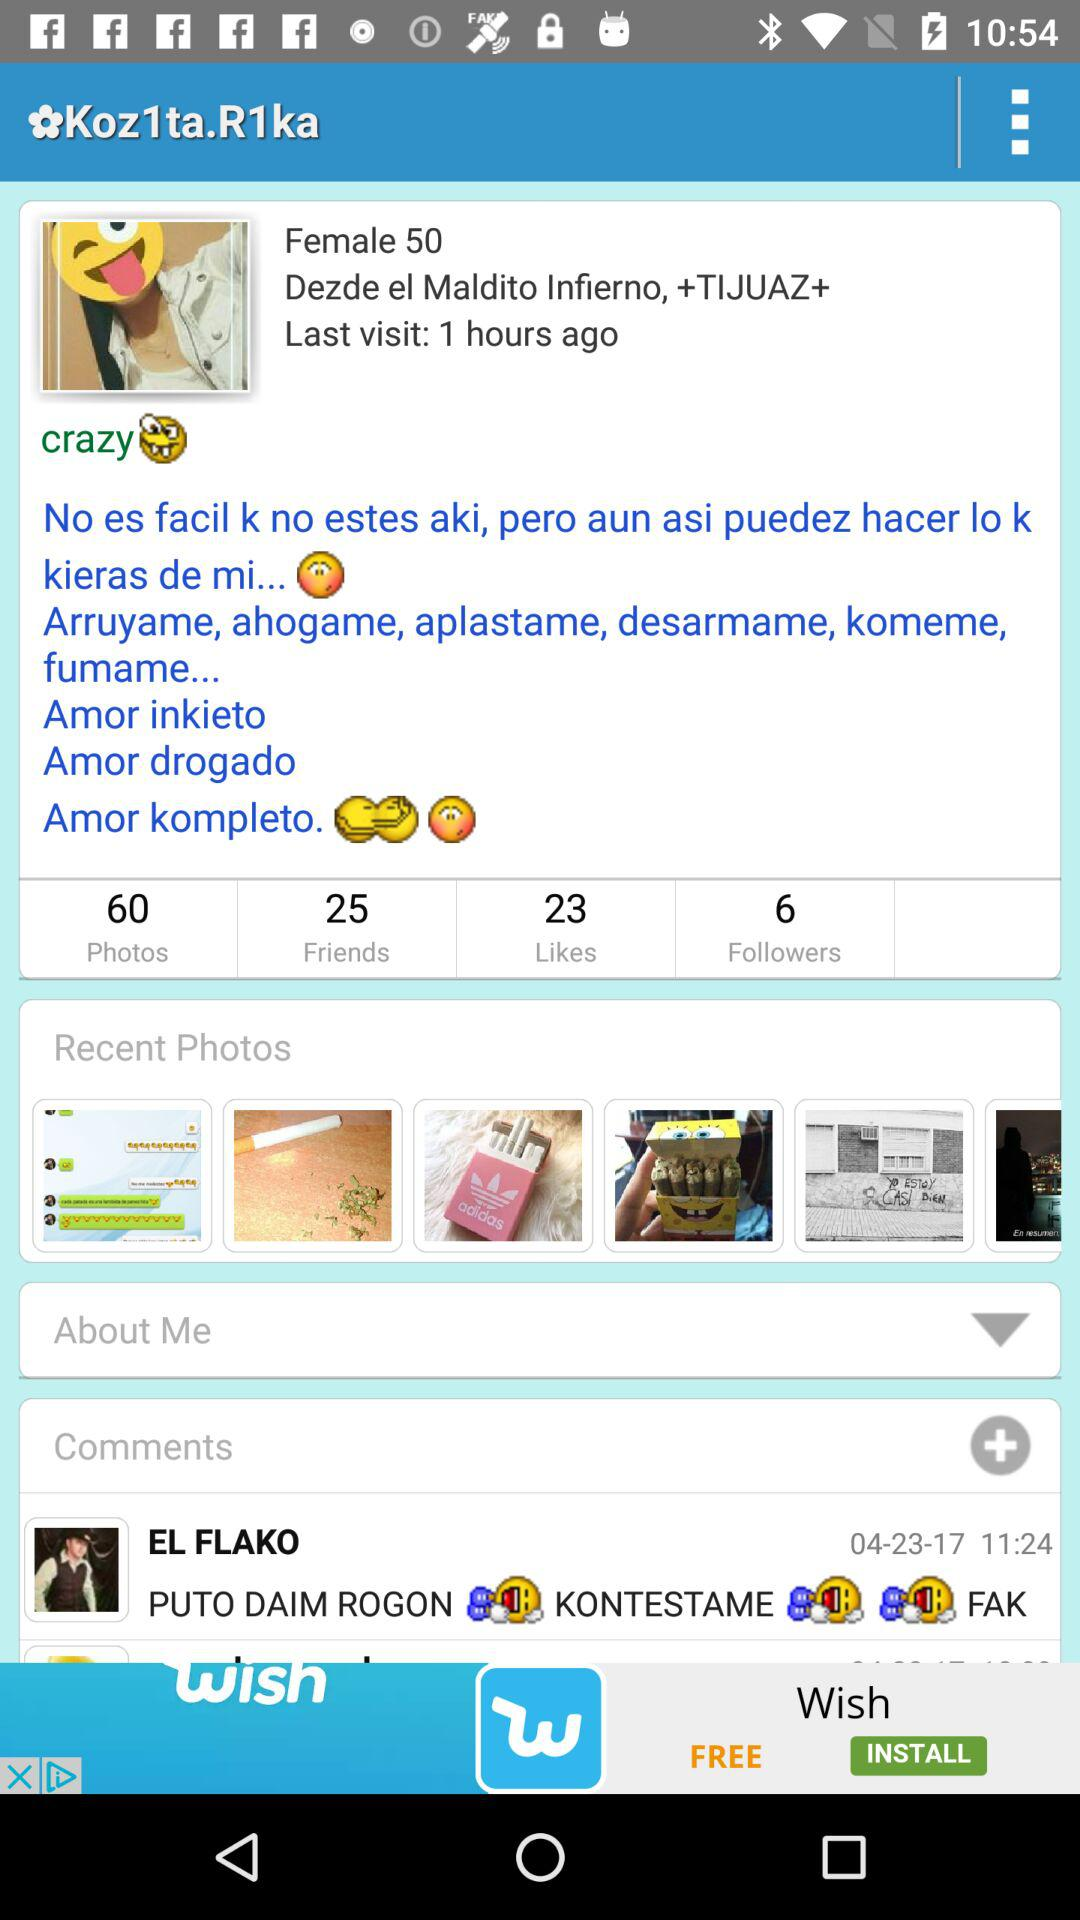What's the female age? The age is 50. 